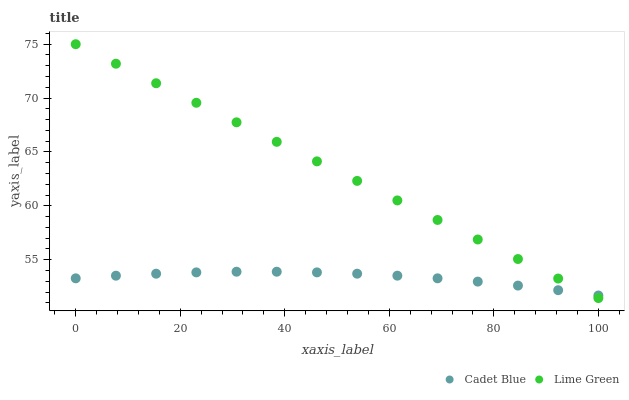Does Cadet Blue have the minimum area under the curve?
Answer yes or no. Yes. Does Lime Green have the maximum area under the curve?
Answer yes or no. Yes. Does Lime Green have the minimum area under the curve?
Answer yes or no. No. Is Lime Green the smoothest?
Answer yes or no. Yes. Is Cadet Blue the roughest?
Answer yes or no. Yes. Is Lime Green the roughest?
Answer yes or no. No. Does Lime Green have the lowest value?
Answer yes or no. Yes. Does Lime Green have the highest value?
Answer yes or no. Yes. Does Lime Green intersect Cadet Blue?
Answer yes or no. Yes. Is Lime Green less than Cadet Blue?
Answer yes or no. No. Is Lime Green greater than Cadet Blue?
Answer yes or no. No. 